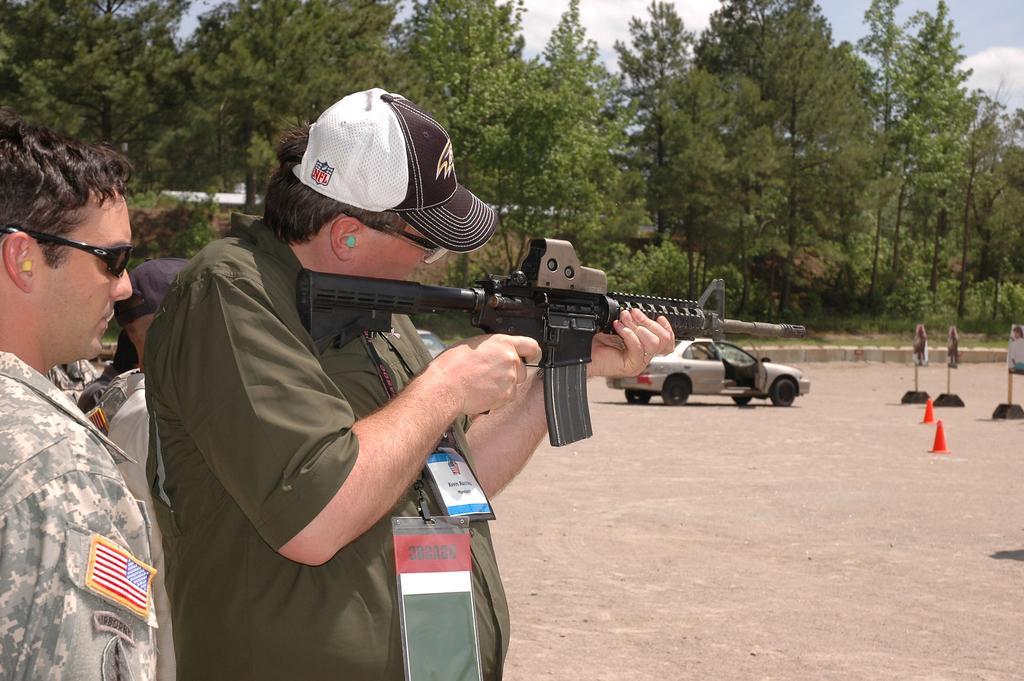How would you summarize this image in a sentence or two? In this image we can see men standing on the ground and one of them is holding a gun in the hands. In the background we can see sky with clouds, trees, road, heap of sand, motor vehicle, traffic cones and barriers. 